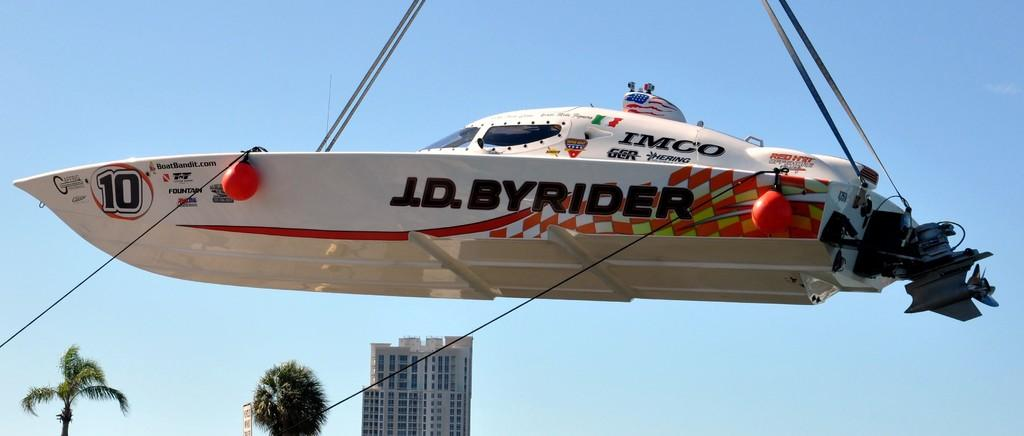What is in the water in the image? There is a boat in the water in the image. What can be seen on top of the boat? There are ropes on top of the boat. Can you describe the rope on the left side of the boat? There is a rope on the left side of the boat. What is visible in the background of the image? There are trees and a building in the background of the image. How many wings can be seen on the boat in the image? There are no wings visible on the boat in the image. What type of mist is covering the trees in the background? There is no mist present in the image; the trees and building are clearly visible in the background. 